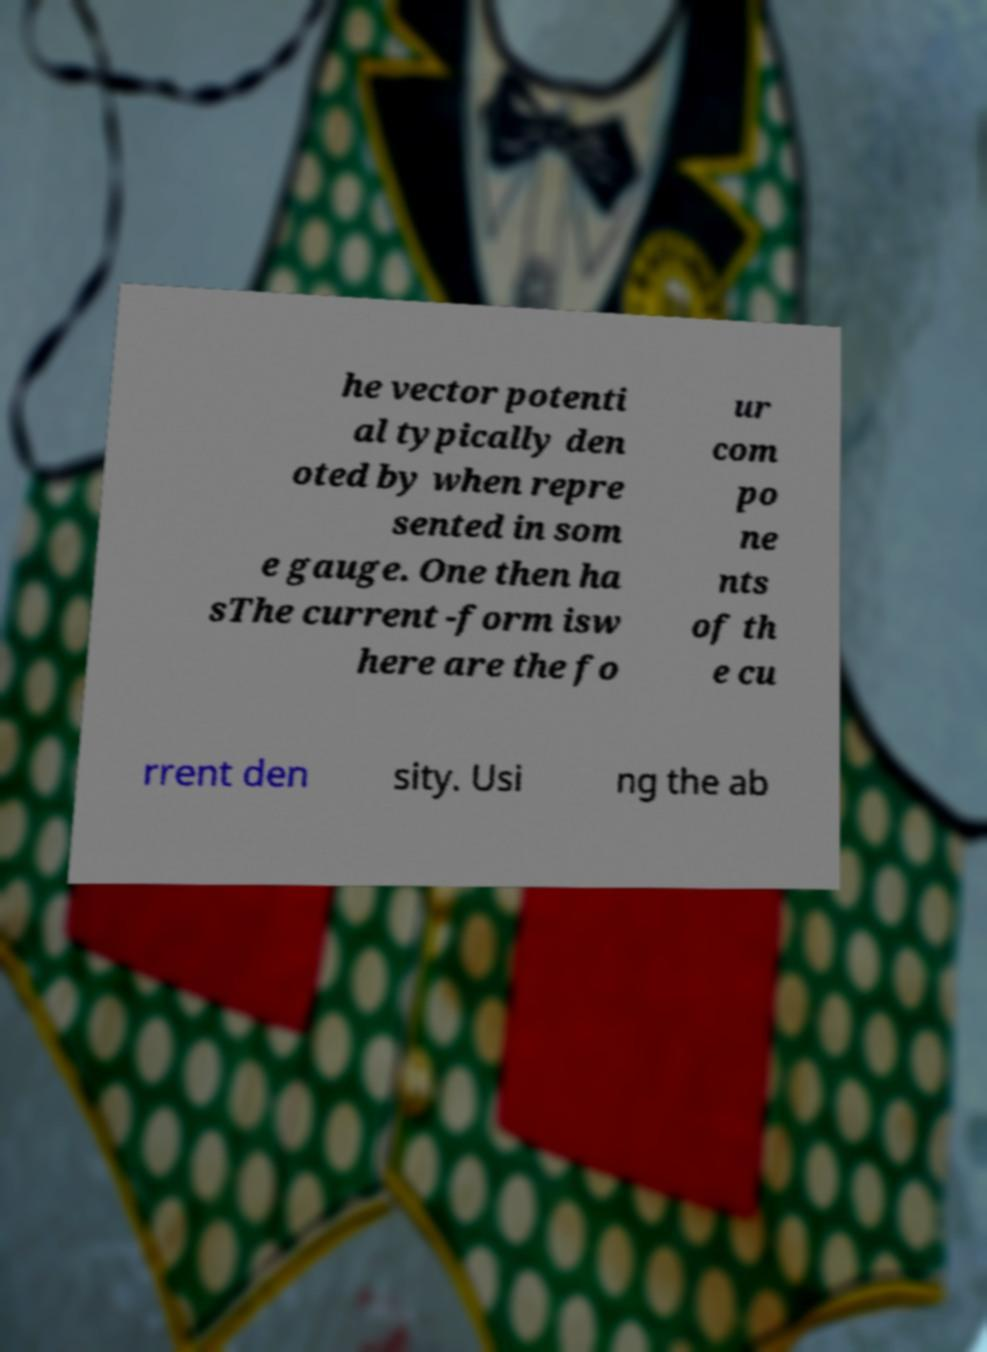Can you accurately transcribe the text from the provided image for me? he vector potenti al typically den oted by when repre sented in som e gauge. One then ha sThe current -form isw here are the fo ur com po ne nts of th e cu rrent den sity. Usi ng the ab 